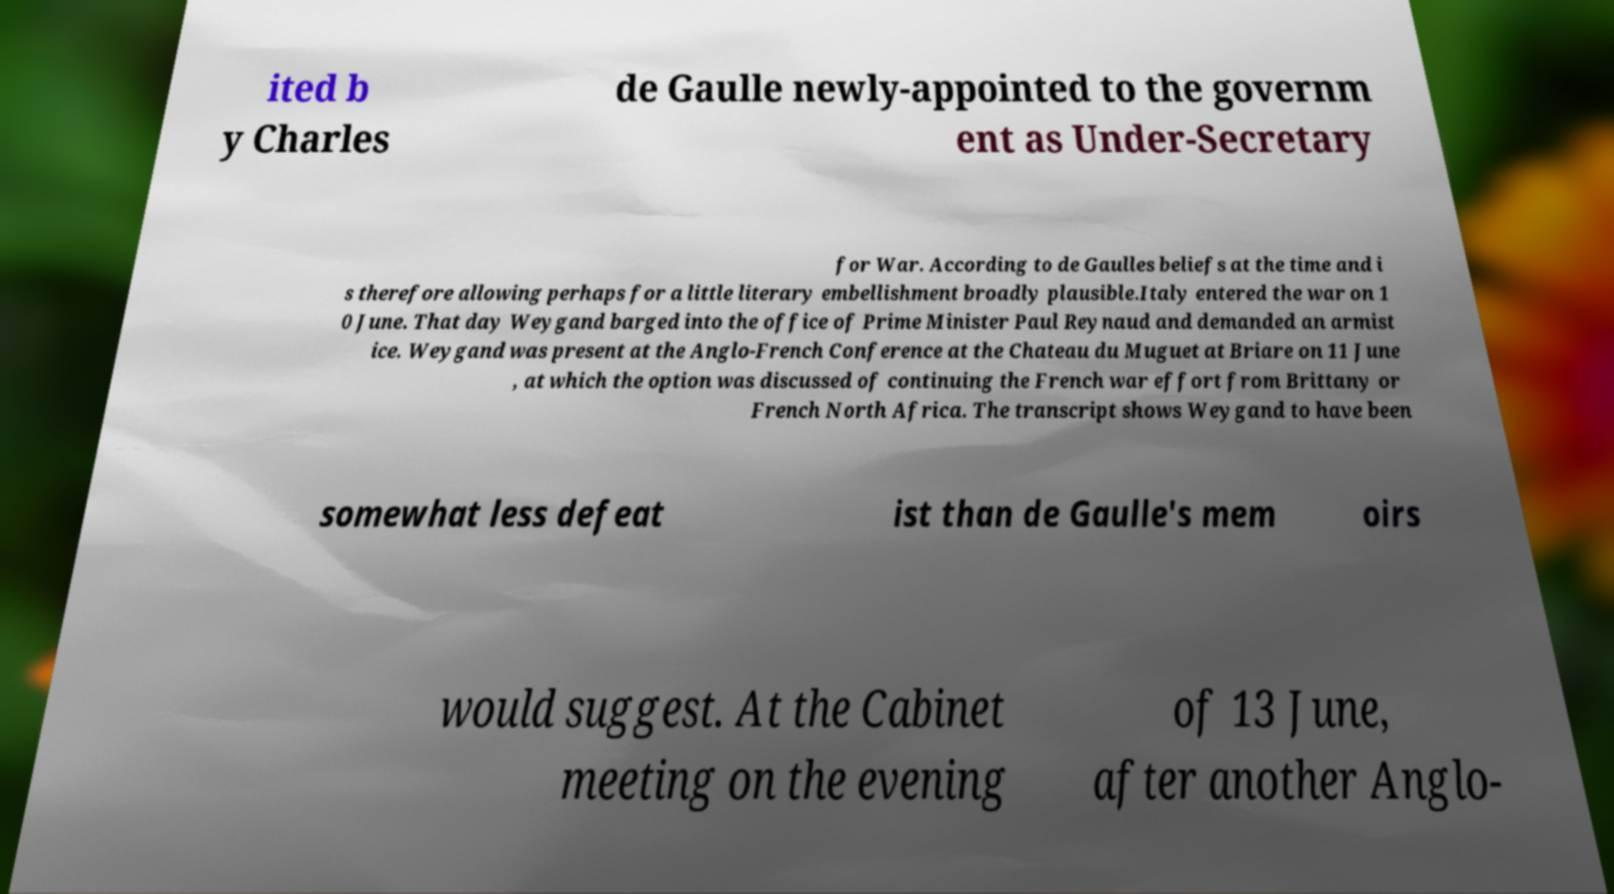Could you assist in decoding the text presented in this image and type it out clearly? ited b y Charles de Gaulle newly-appointed to the governm ent as Under-Secretary for War. According to de Gaulles beliefs at the time and i s therefore allowing perhaps for a little literary embellishment broadly plausible.Italy entered the war on 1 0 June. That day Weygand barged into the office of Prime Minister Paul Reynaud and demanded an armist ice. Weygand was present at the Anglo-French Conference at the Chateau du Muguet at Briare on 11 June , at which the option was discussed of continuing the French war effort from Brittany or French North Africa. The transcript shows Weygand to have been somewhat less defeat ist than de Gaulle's mem oirs would suggest. At the Cabinet meeting on the evening of 13 June, after another Anglo- 